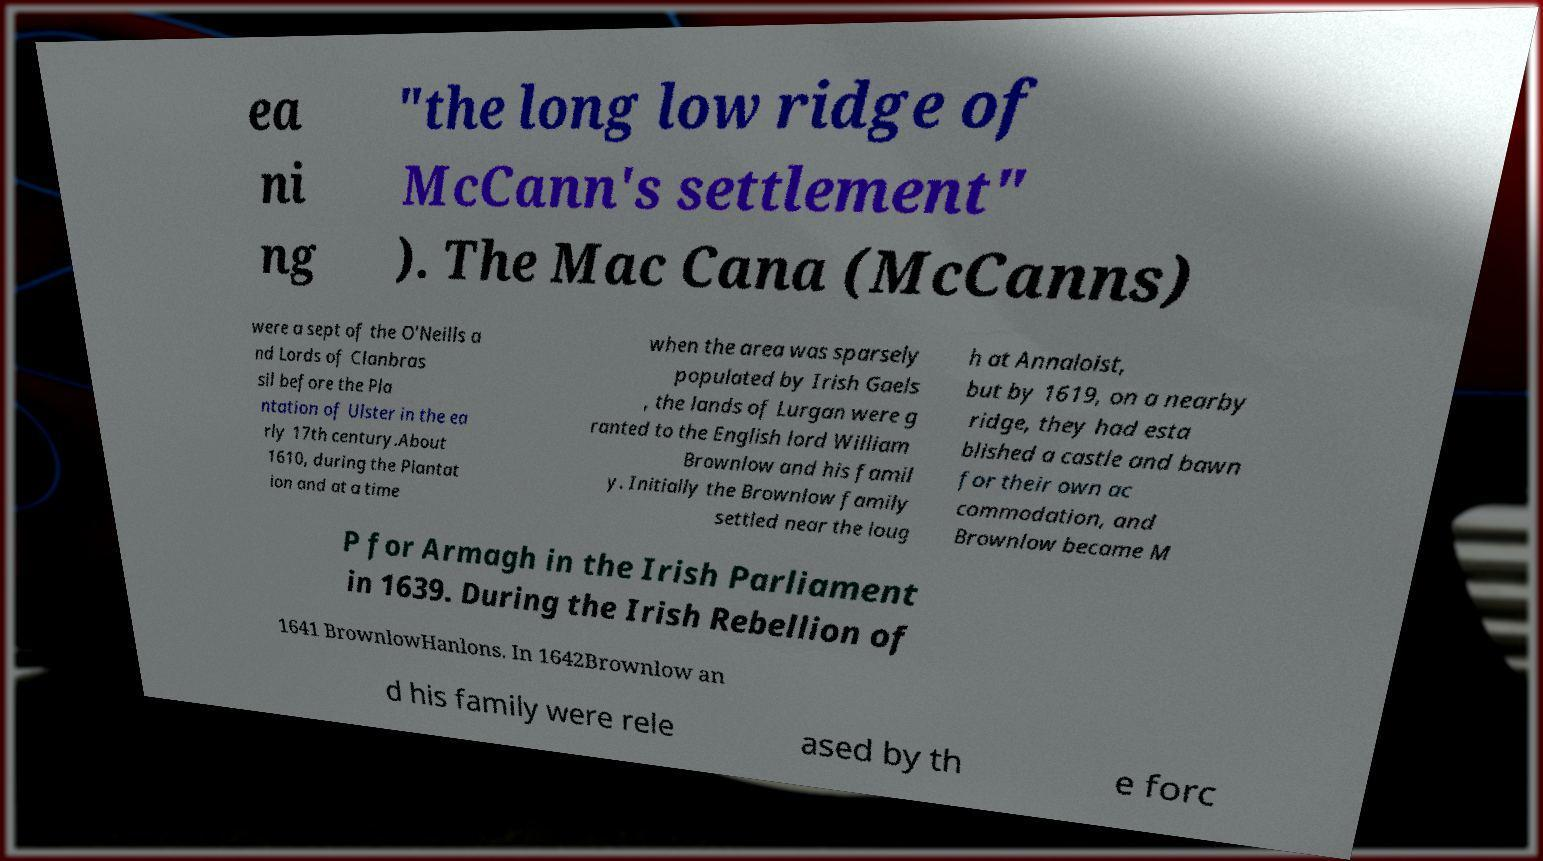Can you accurately transcribe the text from the provided image for me? ea ni ng "the long low ridge of McCann's settlement" ). The Mac Cana (McCanns) were a sept of the O'Neills a nd Lords of Clanbras sil before the Pla ntation of Ulster in the ea rly 17th century.About 1610, during the Plantat ion and at a time when the area was sparsely populated by Irish Gaels , the lands of Lurgan were g ranted to the English lord William Brownlow and his famil y. Initially the Brownlow family settled near the loug h at Annaloist, but by 1619, on a nearby ridge, they had esta blished a castle and bawn for their own ac commodation, and Brownlow became M P for Armagh in the Irish Parliament in 1639. During the Irish Rebellion of 1641 BrownlowHanlons. In 1642Brownlow an d his family were rele ased by th e forc 